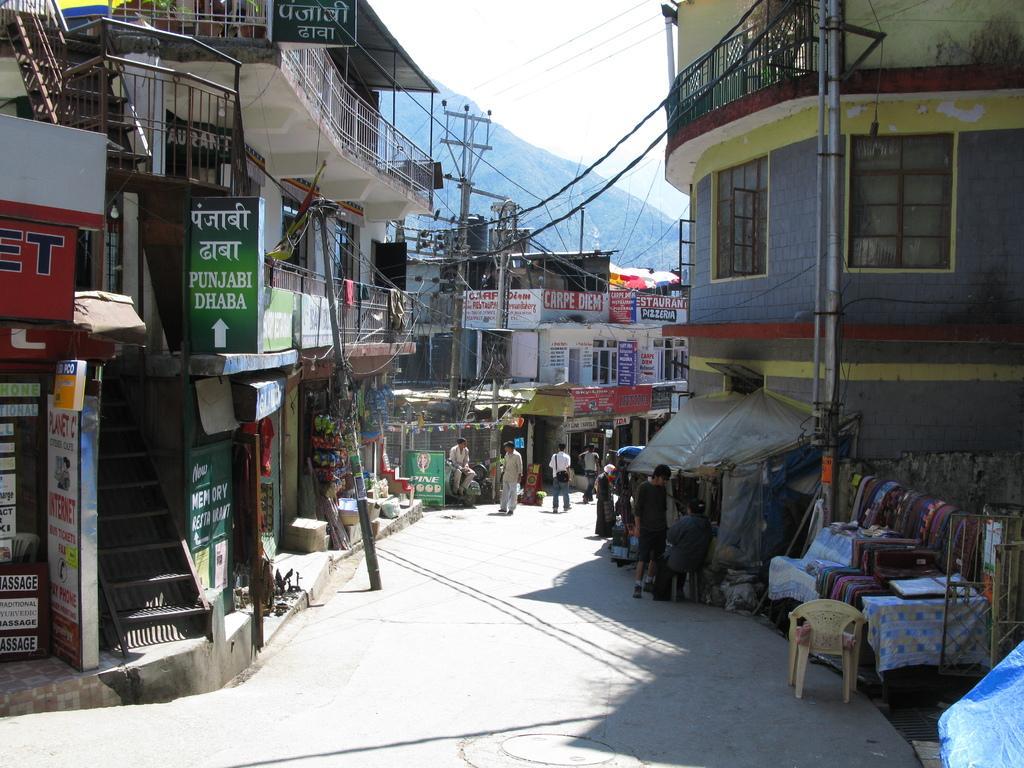Describe this image in one or two sentences. In the middle of the image few people are standing and walking on the road. Behind them there are some poles, buildings and banners. Behind them there is a hill. At the top of the image there is sky. 